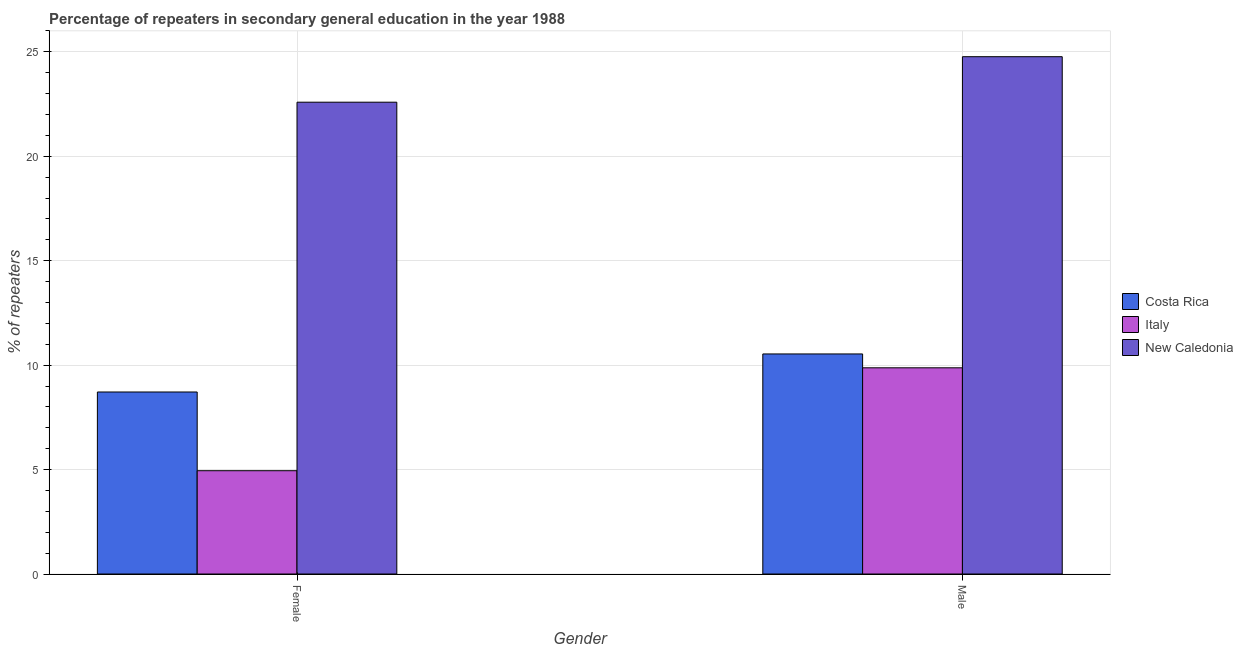How many groups of bars are there?
Provide a short and direct response. 2. Are the number of bars on each tick of the X-axis equal?
Your response must be concise. Yes. What is the percentage of female repeaters in New Caledonia?
Ensure brevity in your answer.  22.59. Across all countries, what is the maximum percentage of male repeaters?
Offer a terse response. 24.77. Across all countries, what is the minimum percentage of male repeaters?
Ensure brevity in your answer.  9.87. In which country was the percentage of male repeaters maximum?
Offer a very short reply. New Caledonia. In which country was the percentage of female repeaters minimum?
Your answer should be compact. Italy. What is the total percentage of female repeaters in the graph?
Provide a succinct answer. 36.24. What is the difference between the percentage of female repeaters in Italy and that in Costa Rica?
Keep it short and to the point. -3.77. What is the difference between the percentage of female repeaters in New Caledonia and the percentage of male repeaters in Costa Rica?
Your response must be concise. 12.05. What is the average percentage of male repeaters per country?
Keep it short and to the point. 15.06. What is the difference between the percentage of female repeaters and percentage of male repeaters in Italy?
Offer a terse response. -4.93. In how many countries, is the percentage of female repeaters greater than 13 %?
Your answer should be compact. 1. What is the ratio of the percentage of male repeaters in Costa Rica to that in New Caledonia?
Your response must be concise. 0.43. In how many countries, is the percentage of female repeaters greater than the average percentage of female repeaters taken over all countries?
Your answer should be very brief. 1. What does the 3rd bar from the right in Male represents?
Offer a terse response. Costa Rica. How many bars are there?
Keep it short and to the point. 6. Does the graph contain grids?
Your answer should be compact. Yes. What is the title of the graph?
Give a very brief answer. Percentage of repeaters in secondary general education in the year 1988. What is the label or title of the Y-axis?
Your answer should be very brief. % of repeaters. What is the % of repeaters in Costa Rica in Female?
Offer a very short reply. 8.71. What is the % of repeaters in Italy in Female?
Provide a short and direct response. 4.94. What is the % of repeaters in New Caledonia in Female?
Your answer should be very brief. 22.59. What is the % of repeaters of Costa Rica in Male?
Offer a very short reply. 10.53. What is the % of repeaters in Italy in Male?
Provide a succinct answer. 9.87. What is the % of repeaters of New Caledonia in Male?
Keep it short and to the point. 24.77. Across all Gender, what is the maximum % of repeaters in Costa Rica?
Your answer should be compact. 10.53. Across all Gender, what is the maximum % of repeaters in Italy?
Your answer should be compact. 9.87. Across all Gender, what is the maximum % of repeaters of New Caledonia?
Keep it short and to the point. 24.77. Across all Gender, what is the minimum % of repeaters in Costa Rica?
Your answer should be very brief. 8.71. Across all Gender, what is the minimum % of repeaters in Italy?
Offer a terse response. 4.94. Across all Gender, what is the minimum % of repeaters of New Caledonia?
Provide a succinct answer. 22.59. What is the total % of repeaters of Costa Rica in the graph?
Keep it short and to the point. 19.25. What is the total % of repeaters of Italy in the graph?
Offer a very short reply. 14.82. What is the total % of repeaters in New Caledonia in the graph?
Keep it short and to the point. 47.35. What is the difference between the % of repeaters in Costa Rica in Female and that in Male?
Offer a terse response. -1.82. What is the difference between the % of repeaters in Italy in Female and that in Male?
Provide a succinct answer. -4.93. What is the difference between the % of repeaters of New Caledonia in Female and that in Male?
Keep it short and to the point. -2.18. What is the difference between the % of repeaters in Costa Rica in Female and the % of repeaters in Italy in Male?
Offer a very short reply. -1.16. What is the difference between the % of repeaters in Costa Rica in Female and the % of repeaters in New Caledonia in Male?
Keep it short and to the point. -16.05. What is the difference between the % of repeaters of Italy in Female and the % of repeaters of New Caledonia in Male?
Your answer should be compact. -19.82. What is the average % of repeaters of Costa Rica per Gender?
Ensure brevity in your answer.  9.62. What is the average % of repeaters of Italy per Gender?
Provide a short and direct response. 7.41. What is the average % of repeaters in New Caledonia per Gender?
Offer a very short reply. 23.68. What is the difference between the % of repeaters in Costa Rica and % of repeaters in Italy in Female?
Offer a very short reply. 3.77. What is the difference between the % of repeaters of Costa Rica and % of repeaters of New Caledonia in Female?
Your answer should be very brief. -13.87. What is the difference between the % of repeaters of Italy and % of repeaters of New Caledonia in Female?
Your answer should be very brief. -17.64. What is the difference between the % of repeaters of Costa Rica and % of repeaters of Italy in Male?
Keep it short and to the point. 0.66. What is the difference between the % of repeaters of Costa Rica and % of repeaters of New Caledonia in Male?
Offer a terse response. -14.23. What is the difference between the % of repeaters in Italy and % of repeaters in New Caledonia in Male?
Ensure brevity in your answer.  -14.89. What is the ratio of the % of repeaters of Costa Rica in Female to that in Male?
Your answer should be compact. 0.83. What is the ratio of the % of repeaters of Italy in Female to that in Male?
Your response must be concise. 0.5. What is the ratio of the % of repeaters of New Caledonia in Female to that in Male?
Offer a terse response. 0.91. What is the difference between the highest and the second highest % of repeaters in Costa Rica?
Give a very brief answer. 1.82. What is the difference between the highest and the second highest % of repeaters in Italy?
Give a very brief answer. 4.93. What is the difference between the highest and the second highest % of repeaters in New Caledonia?
Offer a terse response. 2.18. What is the difference between the highest and the lowest % of repeaters in Costa Rica?
Provide a short and direct response. 1.82. What is the difference between the highest and the lowest % of repeaters in Italy?
Offer a very short reply. 4.93. What is the difference between the highest and the lowest % of repeaters of New Caledonia?
Ensure brevity in your answer.  2.18. 